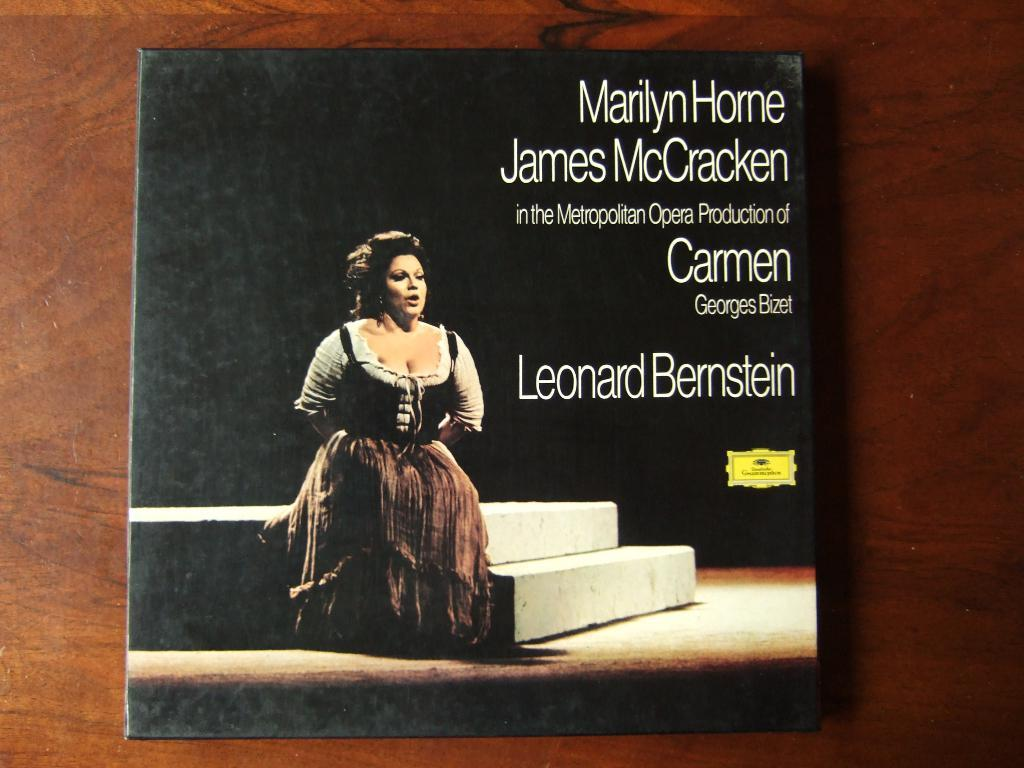<image>
Create a compact narrative representing the image presented. An album cover of Leonard Bernstein music includes a photo of a woman singing opera. 